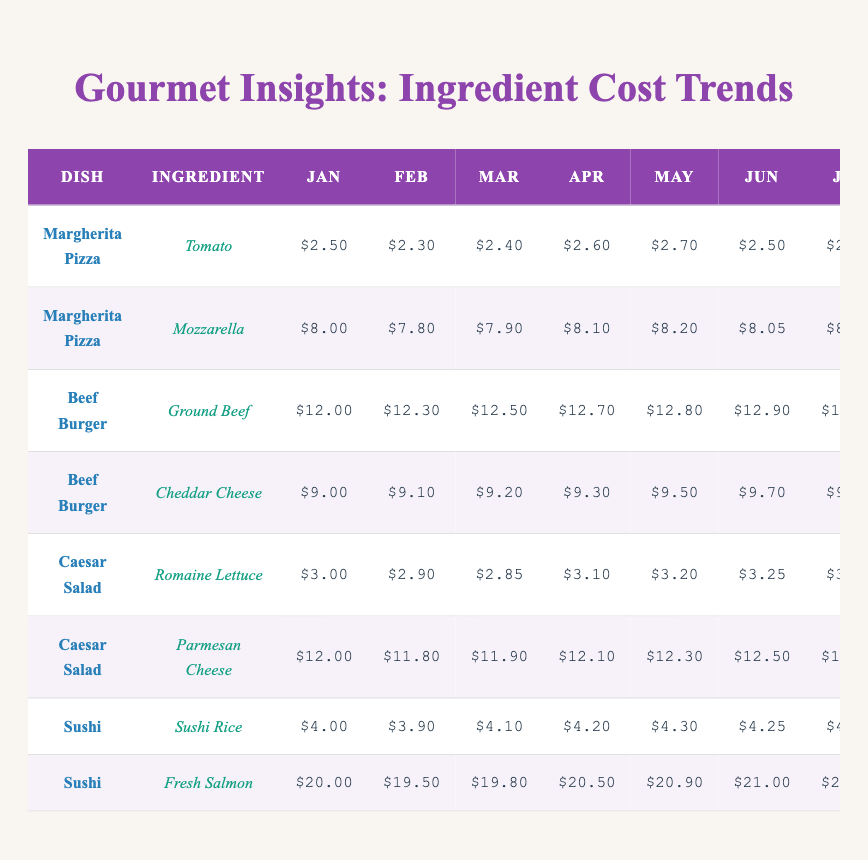What's the cost of tomatoes in December? Looking at the table for the dish Margherita Pizza and the ingredient Tomato, the cost in December is $3.00.
Answer: $3.00 What was the highest cost for mozzarella over the year? By checking the costs for mozzarella, the highest value recorded in December is $9.00.
Answer: $9.00 Which dish had the highest ingredient cost in January? Ground Beef for the Beef Burger costs $12.00, whereas other dish ingredients were lower. Hence, it has the highest cost in January.
Answer: Beef Burger What was the average cost of Cheddar Cheese over the year? The costs are (9.00 + 9.10 + 9.20 + 9.30 + 9.50 + 9.70 + 9.80 + 10.00 + 10.20 + 10.15 + 10.50 + 10.80) = 116.25, which divided by 12 gives an average of $9.69.
Answer: $9.69 Did the cost of Fresh Salmon ever decrease over the year? Reviewing the monthly costs, Fresh Salmon consistently increased each month from January to December, indicating no decrease.
Answer: No What was the percentage increase from the cost of Ground Beef in January to its cost in December? The increase from January ($12.00) to December ($14.00) is calculated as ((14.00 - 12.00) / 12.00) * 100 = 16.67%.
Answer: 16.67% What is the difference in cost between Parmesan Cheese in January and November? Parmesan Cheese cost $12.00 in January and $13.20 in November, leading to a difference of 13.20 - 12.00 = $1.20.
Answer: $1.20 Which ingredient for Margherita Pizza had the lowest maximum cost during the year? The maximum cost for Tomato was $3.00 and for Mozzarella was $9.00; hence Tomato had the lowest maximum cost.
Answer: Tomato What is the total cost of all ingredients for Beef Burger in December? The costs in December are Ground Beef ($14.00) and Cheddar Cheese ($10.80); adding them gives 14.00 + 10.80 = $24.80.
Answer: $24.80 In which month did the cost of Romaine Lettuce peak? By reviewing the costs, the highest price recorded for Romaine Lettuce was $3.80 in December.
Answer: December 